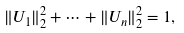<formula> <loc_0><loc_0><loc_500><loc_500>\| U _ { 1 } \| _ { 2 } ^ { 2 } + \cdots + \| U _ { n } \| _ { 2 } ^ { 2 } = 1 ,</formula> 